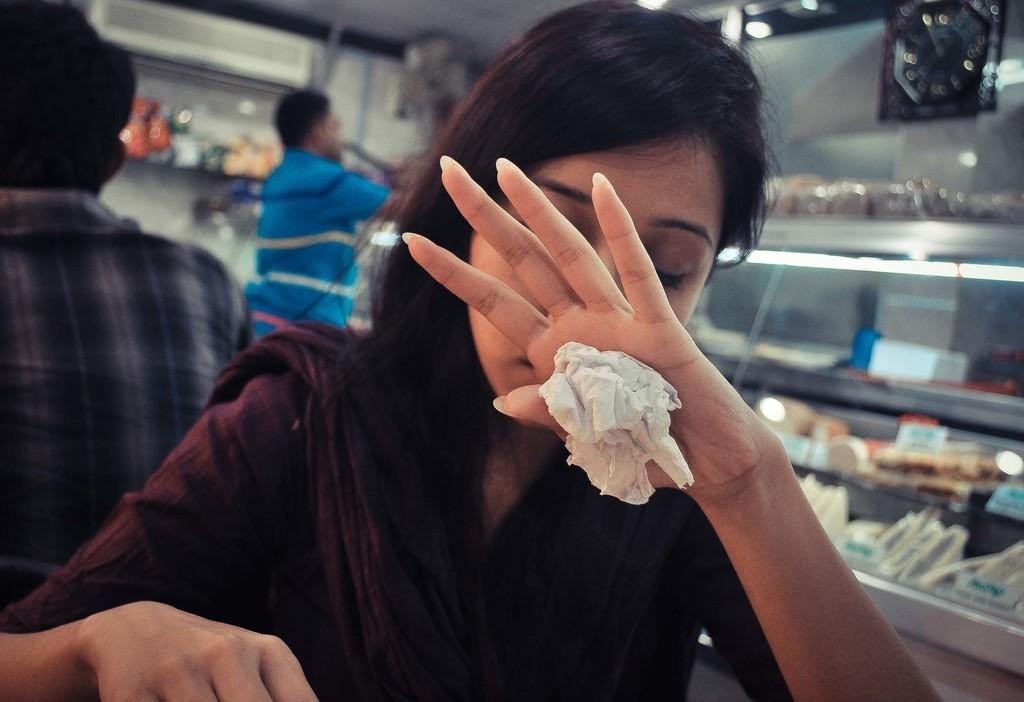Who is the main subject in the image? There is a girl in the image. What is the girl holding in the image? The girl is holding a tissue. What can be seen on the right side of the image? There are many food items on the right side of the image. What type of location does the image appear to depict? The setting appears to be a bakery. Can you describe the people in the background of the image? There are two men standing in the background of the image. What type of hearing aid is the girl wearing in the image? There is no hearing aid visible in the image; the girl is holding a tissue. 